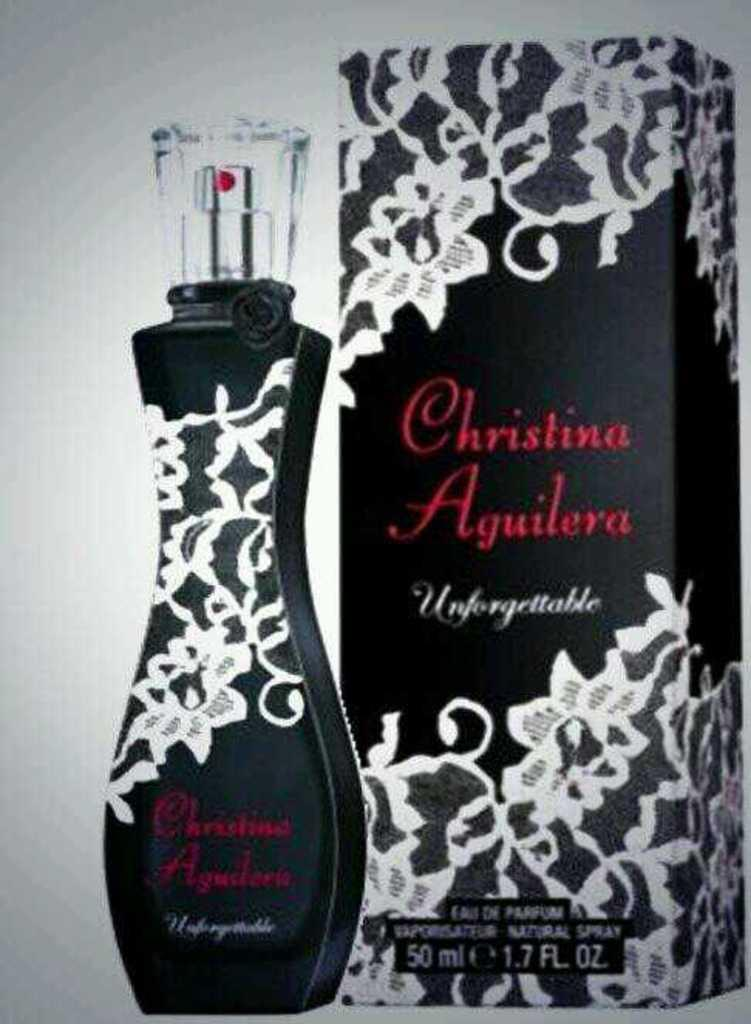<image>
Provide a brief description of the given image. Christina Aguilera Unforgettable Eau de Parfum bottle next to the box it comes in. 